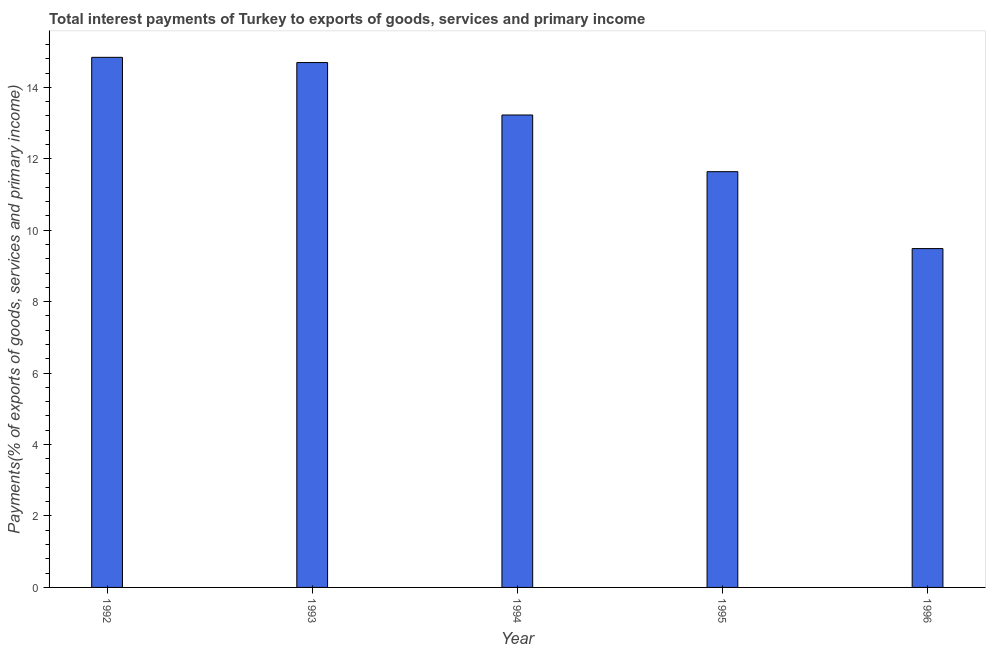Does the graph contain any zero values?
Make the answer very short. No. Does the graph contain grids?
Make the answer very short. No. What is the title of the graph?
Your answer should be compact. Total interest payments of Turkey to exports of goods, services and primary income. What is the label or title of the X-axis?
Provide a succinct answer. Year. What is the label or title of the Y-axis?
Your answer should be very brief. Payments(% of exports of goods, services and primary income). What is the total interest payments on external debt in 1992?
Ensure brevity in your answer.  14.84. Across all years, what is the maximum total interest payments on external debt?
Provide a succinct answer. 14.84. Across all years, what is the minimum total interest payments on external debt?
Your answer should be compact. 9.49. In which year was the total interest payments on external debt maximum?
Give a very brief answer. 1992. In which year was the total interest payments on external debt minimum?
Make the answer very short. 1996. What is the sum of the total interest payments on external debt?
Provide a succinct answer. 63.88. What is the difference between the total interest payments on external debt in 1992 and 1995?
Your response must be concise. 3.2. What is the average total interest payments on external debt per year?
Give a very brief answer. 12.78. What is the median total interest payments on external debt?
Provide a succinct answer. 13.23. In how many years, is the total interest payments on external debt greater than 1.2 %?
Your response must be concise. 5. Do a majority of the years between 1993 and 1996 (inclusive) have total interest payments on external debt greater than 7.2 %?
Provide a succinct answer. Yes. What is the ratio of the total interest payments on external debt in 1993 to that in 1996?
Your response must be concise. 1.55. Is the total interest payments on external debt in 1995 less than that in 1996?
Provide a short and direct response. No. What is the difference between the highest and the second highest total interest payments on external debt?
Your answer should be very brief. 0.15. What is the difference between the highest and the lowest total interest payments on external debt?
Offer a very short reply. 5.35. How many bars are there?
Ensure brevity in your answer.  5. What is the Payments(% of exports of goods, services and primary income) in 1992?
Provide a short and direct response. 14.84. What is the Payments(% of exports of goods, services and primary income) in 1993?
Make the answer very short. 14.69. What is the Payments(% of exports of goods, services and primary income) in 1994?
Your response must be concise. 13.23. What is the Payments(% of exports of goods, services and primary income) of 1995?
Provide a succinct answer. 11.64. What is the Payments(% of exports of goods, services and primary income) of 1996?
Make the answer very short. 9.49. What is the difference between the Payments(% of exports of goods, services and primary income) in 1992 and 1993?
Give a very brief answer. 0.15. What is the difference between the Payments(% of exports of goods, services and primary income) in 1992 and 1994?
Make the answer very short. 1.61. What is the difference between the Payments(% of exports of goods, services and primary income) in 1992 and 1995?
Your answer should be compact. 3.2. What is the difference between the Payments(% of exports of goods, services and primary income) in 1992 and 1996?
Keep it short and to the point. 5.35. What is the difference between the Payments(% of exports of goods, services and primary income) in 1993 and 1994?
Offer a very short reply. 1.47. What is the difference between the Payments(% of exports of goods, services and primary income) in 1993 and 1995?
Offer a very short reply. 3.05. What is the difference between the Payments(% of exports of goods, services and primary income) in 1993 and 1996?
Offer a very short reply. 5.21. What is the difference between the Payments(% of exports of goods, services and primary income) in 1994 and 1995?
Offer a terse response. 1.59. What is the difference between the Payments(% of exports of goods, services and primary income) in 1994 and 1996?
Your response must be concise. 3.74. What is the difference between the Payments(% of exports of goods, services and primary income) in 1995 and 1996?
Ensure brevity in your answer.  2.15. What is the ratio of the Payments(% of exports of goods, services and primary income) in 1992 to that in 1994?
Your answer should be compact. 1.12. What is the ratio of the Payments(% of exports of goods, services and primary income) in 1992 to that in 1995?
Offer a very short reply. 1.27. What is the ratio of the Payments(% of exports of goods, services and primary income) in 1992 to that in 1996?
Give a very brief answer. 1.56. What is the ratio of the Payments(% of exports of goods, services and primary income) in 1993 to that in 1994?
Make the answer very short. 1.11. What is the ratio of the Payments(% of exports of goods, services and primary income) in 1993 to that in 1995?
Your answer should be very brief. 1.26. What is the ratio of the Payments(% of exports of goods, services and primary income) in 1993 to that in 1996?
Make the answer very short. 1.55. What is the ratio of the Payments(% of exports of goods, services and primary income) in 1994 to that in 1995?
Ensure brevity in your answer.  1.14. What is the ratio of the Payments(% of exports of goods, services and primary income) in 1994 to that in 1996?
Offer a terse response. 1.39. What is the ratio of the Payments(% of exports of goods, services and primary income) in 1995 to that in 1996?
Offer a very short reply. 1.23. 